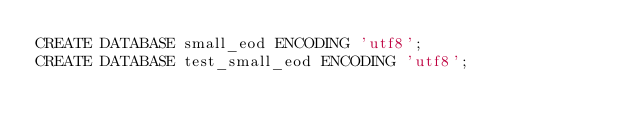Convert code to text. <code><loc_0><loc_0><loc_500><loc_500><_SQL_>CREATE DATABASE small_eod ENCODING 'utf8';
CREATE DATABASE test_small_eod ENCODING 'utf8';
</code> 